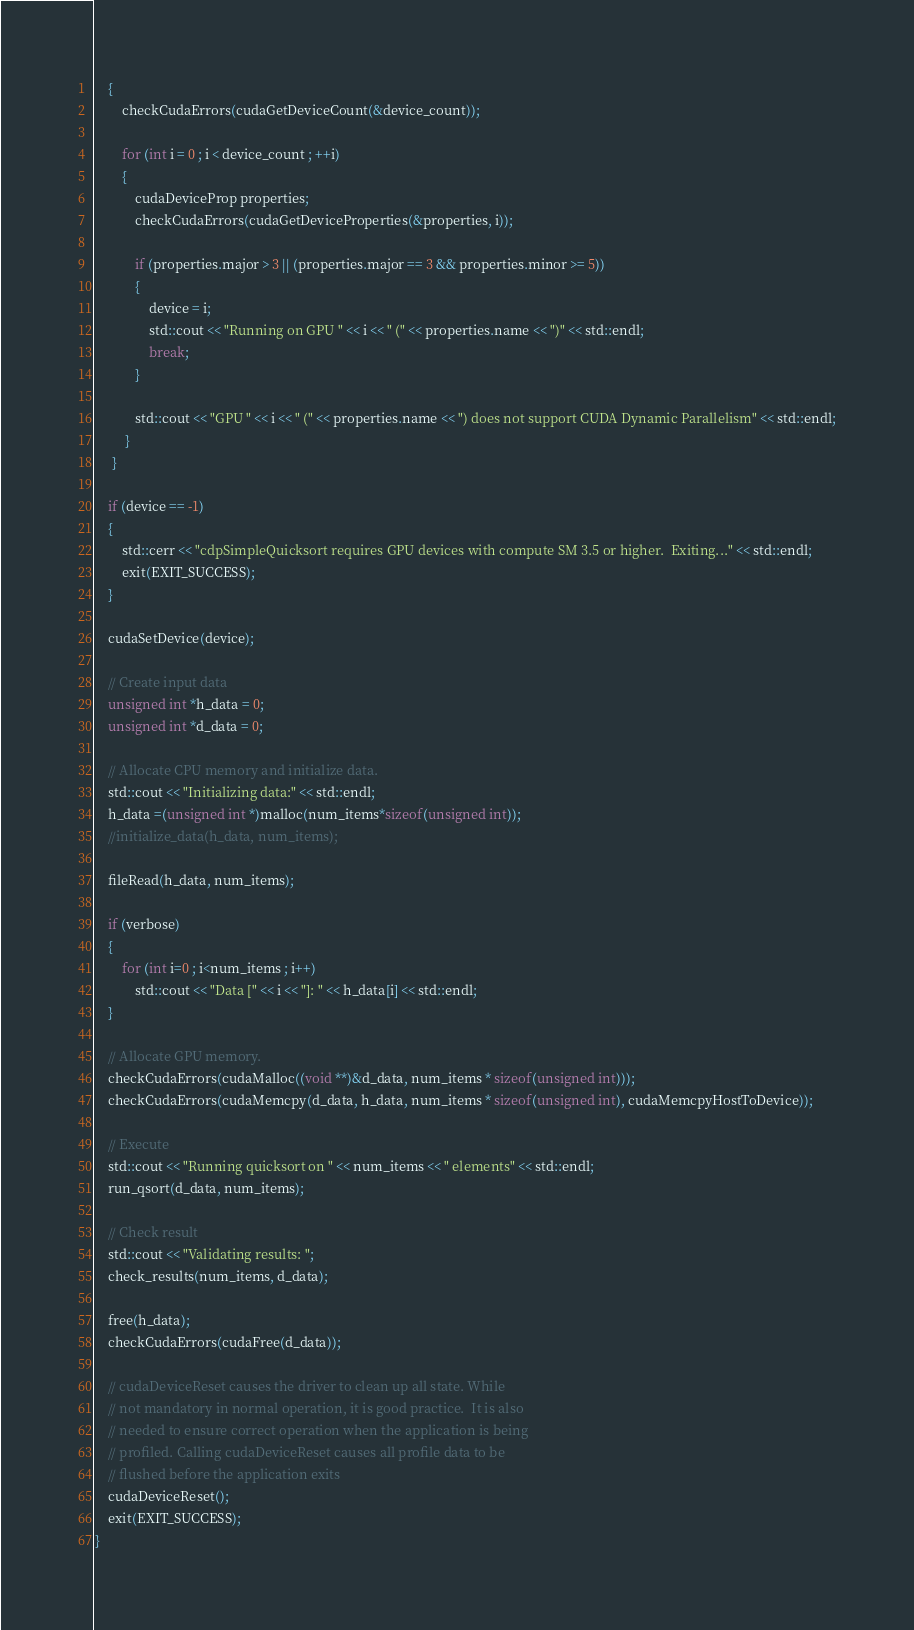<code> <loc_0><loc_0><loc_500><loc_500><_Cuda_>    {
        checkCudaErrors(cudaGetDeviceCount(&device_count));
    
        for (int i = 0 ; i < device_count ; ++i)
        {
            cudaDeviceProp properties;
            checkCudaErrors(cudaGetDeviceProperties(&properties, i));

            if (properties.major > 3 || (properties.major == 3 && properties.minor >= 5))
            {
                device = i;
                std::cout << "Running on GPU " << i << " (" << properties.name << ")" << std::endl;
                break;
            }

            std::cout << "GPU " << i << " (" << properties.name << ") does not support CUDA Dynamic Parallelism" << std::endl;
         }
     }

    if (device == -1)
    {
        std::cerr << "cdpSimpleQuicksort requires GPU devices with compute SM 3.5 or higher.  Exiting..." << std::endl;
        exit(EXIT_SUCCESS);
    }

    cudaSetDevice(device);

    // Create input data
    unsigned int *h_data = 0;
    unsigned int *d_data = 0;

    // Allocate CPU memory and initialize data.
    std::cout << "Initializing data:" << std::endl;
    h_data =(unsigned int *)malloc(num_items*sizeof(unsigned int));
    //initialize_data(h_data, num_items);

    fileRead(h_data, num_items);

    if (verbose)
    {
        for (int i=0 ; i<num_items ; i++)
            std::cout << "Data [" << i << "]: " << h_data[i] << std::endl;
    }

    // Allocate GPU memory.
    checkCudaErrors(cudaMalloc((void **)&d_data, num_items * sizeof(unsigned int)));
    checkCudaErrors(cudaMemcpy(d_data, h_data, num_items * sizeof(unsigned int), cudaMemcpyHostToDevice));

    // Execute
    std::cout << "Running quicksort on " << num_items << " elements" << std::endl;
    run_qsort(d_data, num_items);

    // Check result
    std::cout << "Validating results: ";
    check_results(num_items, d_data);

    free(h_data);
    checkCudaErrors(cudaFree(d_data));

    // cudaDeviceReset causes the driver to clean up all state. While
    // not mandatory in normal operation, it is good practice.  It is also
    // needed to ensure correct operation when the application is being
    // profiled. Calling cudaDeviceReset causes all profile data to be
    // flushed before the application exits
    cudaDeviceReset();
    exit(EXIT_SUCCESS);
}

</code> 